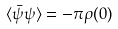<formula> <loc_0><loc_0><loc_500><loc_500>\langle \bar { \psi } \psi \rangle = - \pi \rho ( 0 )</formula> 